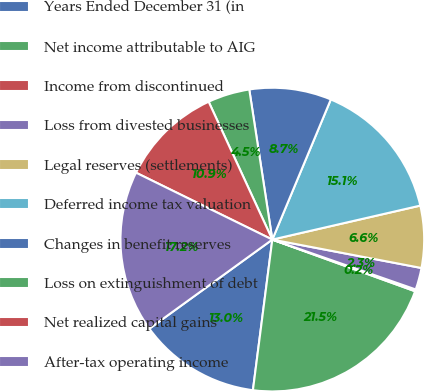Convert chart. <chart><loc_0><loc_0><loc_500><loc_500><pie_chart><fcel>Years Ended December 31 (in<fcel>Net income attributable to AIG<fcel>Income from discontinued<fcel>Loss from divested businesses<fcel>Legal reserves (settlements)<fcel>Deferred income tax valuation<fcel>Changes in benefit reserves<fcel>Loss on extinguishment of debt<fcel>Net realized capital gains<fcel>After-tax operating income<nl><fcel>12.98%<fcel>21.51%<fcel>0.2%<fcel>2.33%<fcel>6.59%<fcel>15.11%<fcel>8.72%<fcel>4.46%<fcel>10.85%<fcel>17.24%<nl></chart> 